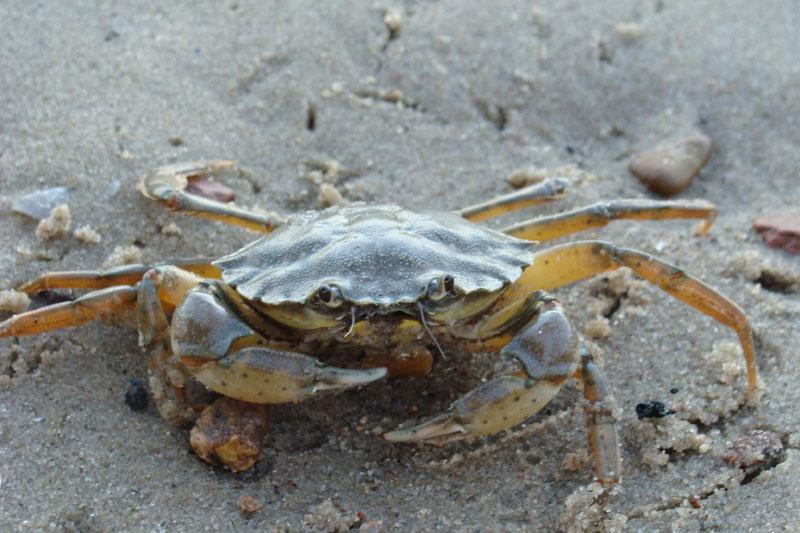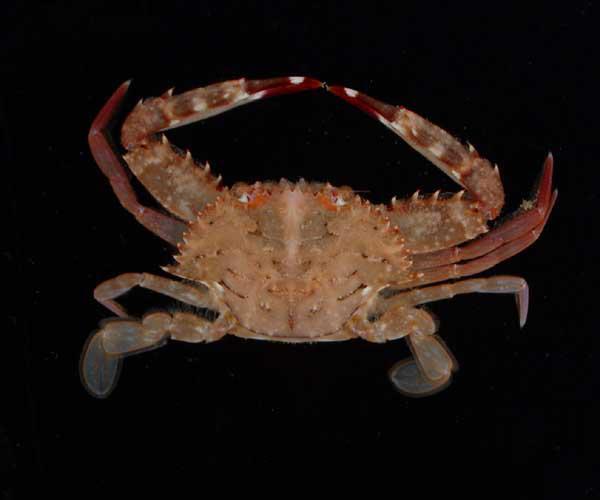The first image is the image on the left, the second image is the image on the right. Considering the images on both sides, is "The left image shows a mass of crabs with their purplish-grayish shells facing up, and the right image shows one crab toward the bottom of the seabed facing forward at an angle." valid? Answer yes or no. No. The first image is the image on the left, the second image is the image on the right. Examine the images to the left and right. Is the description "Atleast one picture of a crab in water." accurate? Answer yes or no. No. 